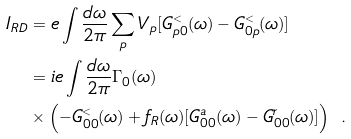Convert formula to latex. <formula><loc_0><loc_0><loc_500><loc_500>I _ { R D } & = e \int \frac { d \omega } { 2 \pi } \sum _ { p } V _ { p } [ G ^ { < } _ { p 0 } ( \omega ) - G ^ { < } _ { 0 p } ( \omega ) ] \\ & = i e \int \frac { d \omega } { 2 \pi } \Gamma _ { 0 } ( \omega ) \\ & \times \left ( - G ^ { < } _ { 0 0 } ( \omega ) + f _ { R } ( \omega ) [ G ^ { a } _ { 0 0 } ( \omega ) - G ^ { r } _ { 0 0 } ( \omega ) ] \right ) \ .</formula> 